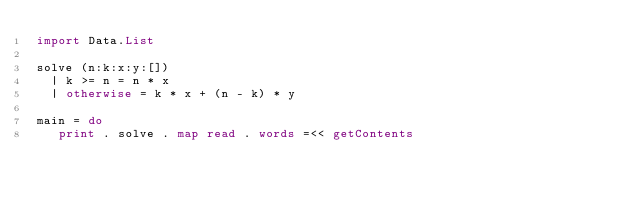Convert code to text. <code><loc_0><loc_0><loc_500><loc_500><_Haskell_>import Data.List

solve (n:k:x:y:[])
  | k >= n = n * x
  | otherwise = k * x + (n - k) * y

main = do
   print . solve . map read . words =<< getContents
</code> 